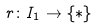Convert formula to latex. <formula><loc_0><loc_0><loc_500><loc_500>r \colon I _ { 1 } \to \{ * \}</formula> 